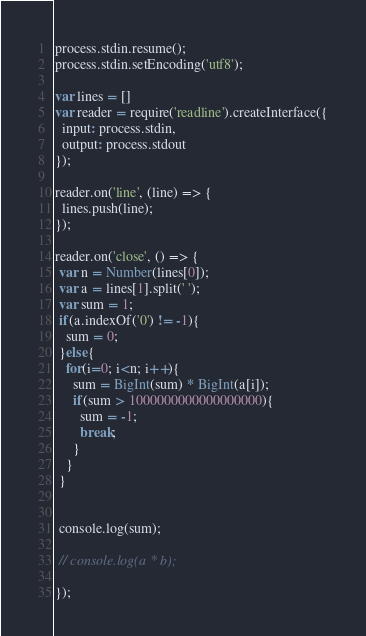<code> <loc_0><loc_0><loc_500><loc_500><_JavaScript_>process.stdin.resume();
process.stdin.setEncoding('utf8');

var lines = []
var reader = require('readline').createInterface({
  input: process.stdin,
  output: process.stdout
});

reader.on('line', (line) => {
  lines.push(line);
});

reader.on('close', () => {
 var n = Number(lines[0]);
 var a = lines[1].split(' ');
 var sum = 1;
 if(a.indexOf('0') != -1){
   sum = 0;
 }else{
   for(i=0; i<n; i++){
     sum = BigInt(sum) * BigInt(a[i]);
     if(sum > 1000000000000000000){
       sum = -1;
       break;
     }
   }
 }
 

 console.log(sum);

 // console.log(a * b);
 
});</code> 